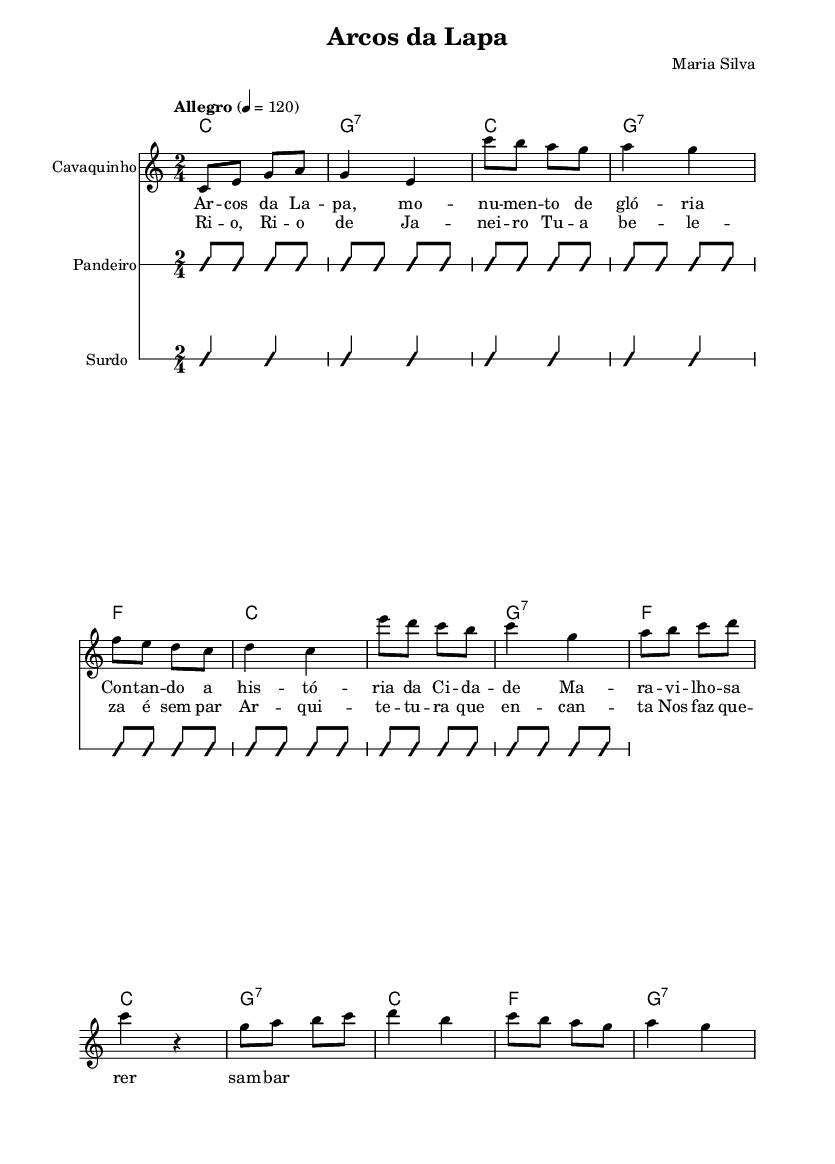What is the key signature of this music? The key signature is C major, which has no sharps or flats indicated at the beginning of the staff.
Answer: C major What is the time signature of this song? The time signature shown in the first system of the music is 2/4, which means there are two beats in each measure with a quarter note getting one beat.
Answer: 2/4 What is the tempo marking for this piece? The tempo marking indicates "Allegro" at a speed of 120 beats per minute, which is typically fast and lively in nature.
Answer: Allegro 4 = 120 What instrument is indicated for the melody? The instrument designated for playing the melody in the first staff is a "Cavaquinho," which is a traditional Brazilian string instrument.
Answer: Cavaquinho How many measures are in the chorus section? By analyzing the chorus lyrics and counting the measures in the corresponding melodic line, there are four measures in the chorus section.
Answer: 4 What architectural feature is celebrated in the lyrics of this song? The lyrics mention "Arcos da Lapa," which refers to the iconic aqueduct and architectural landmark in Rio de Janeiro.
Answer: Arcos da Lapa In what context do the lyrics mention Rio de Janeiro? The lyrics use the phrase "Rio de Janeiro" in admiration to express the beauty and allure of the city, specifically celebrating its architecture within the song.
Answer: Beauty 